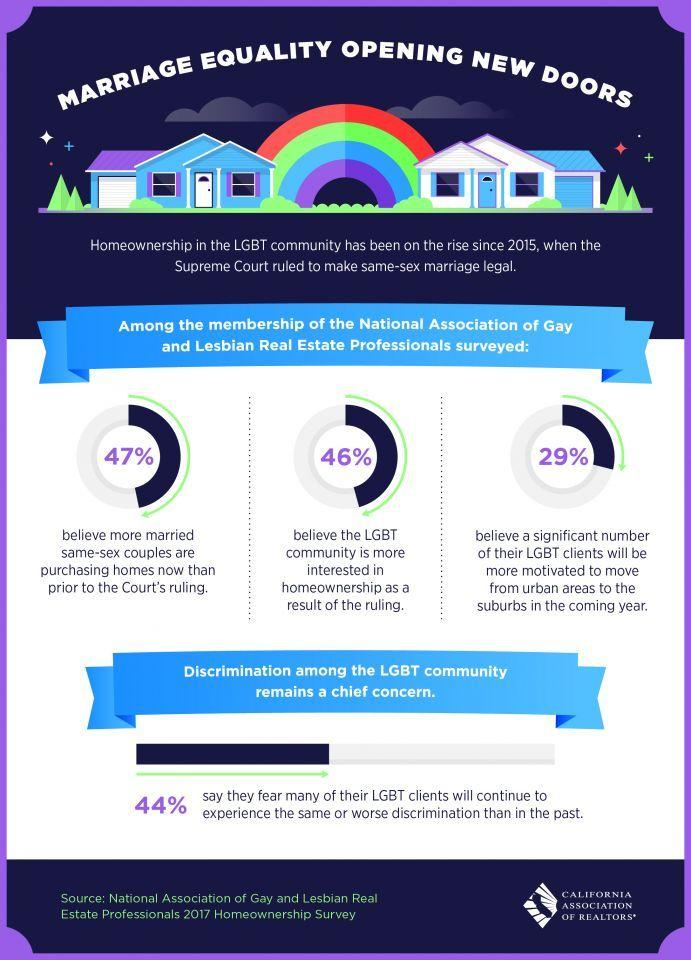Outline some significant characteristics in this image. According to the survey, 29% of people believe that LGBT individuals are likely to move from urban areas to suburban areas in the future. Forty-six percent of LGBT individuals report an increased interest in homeownership. 